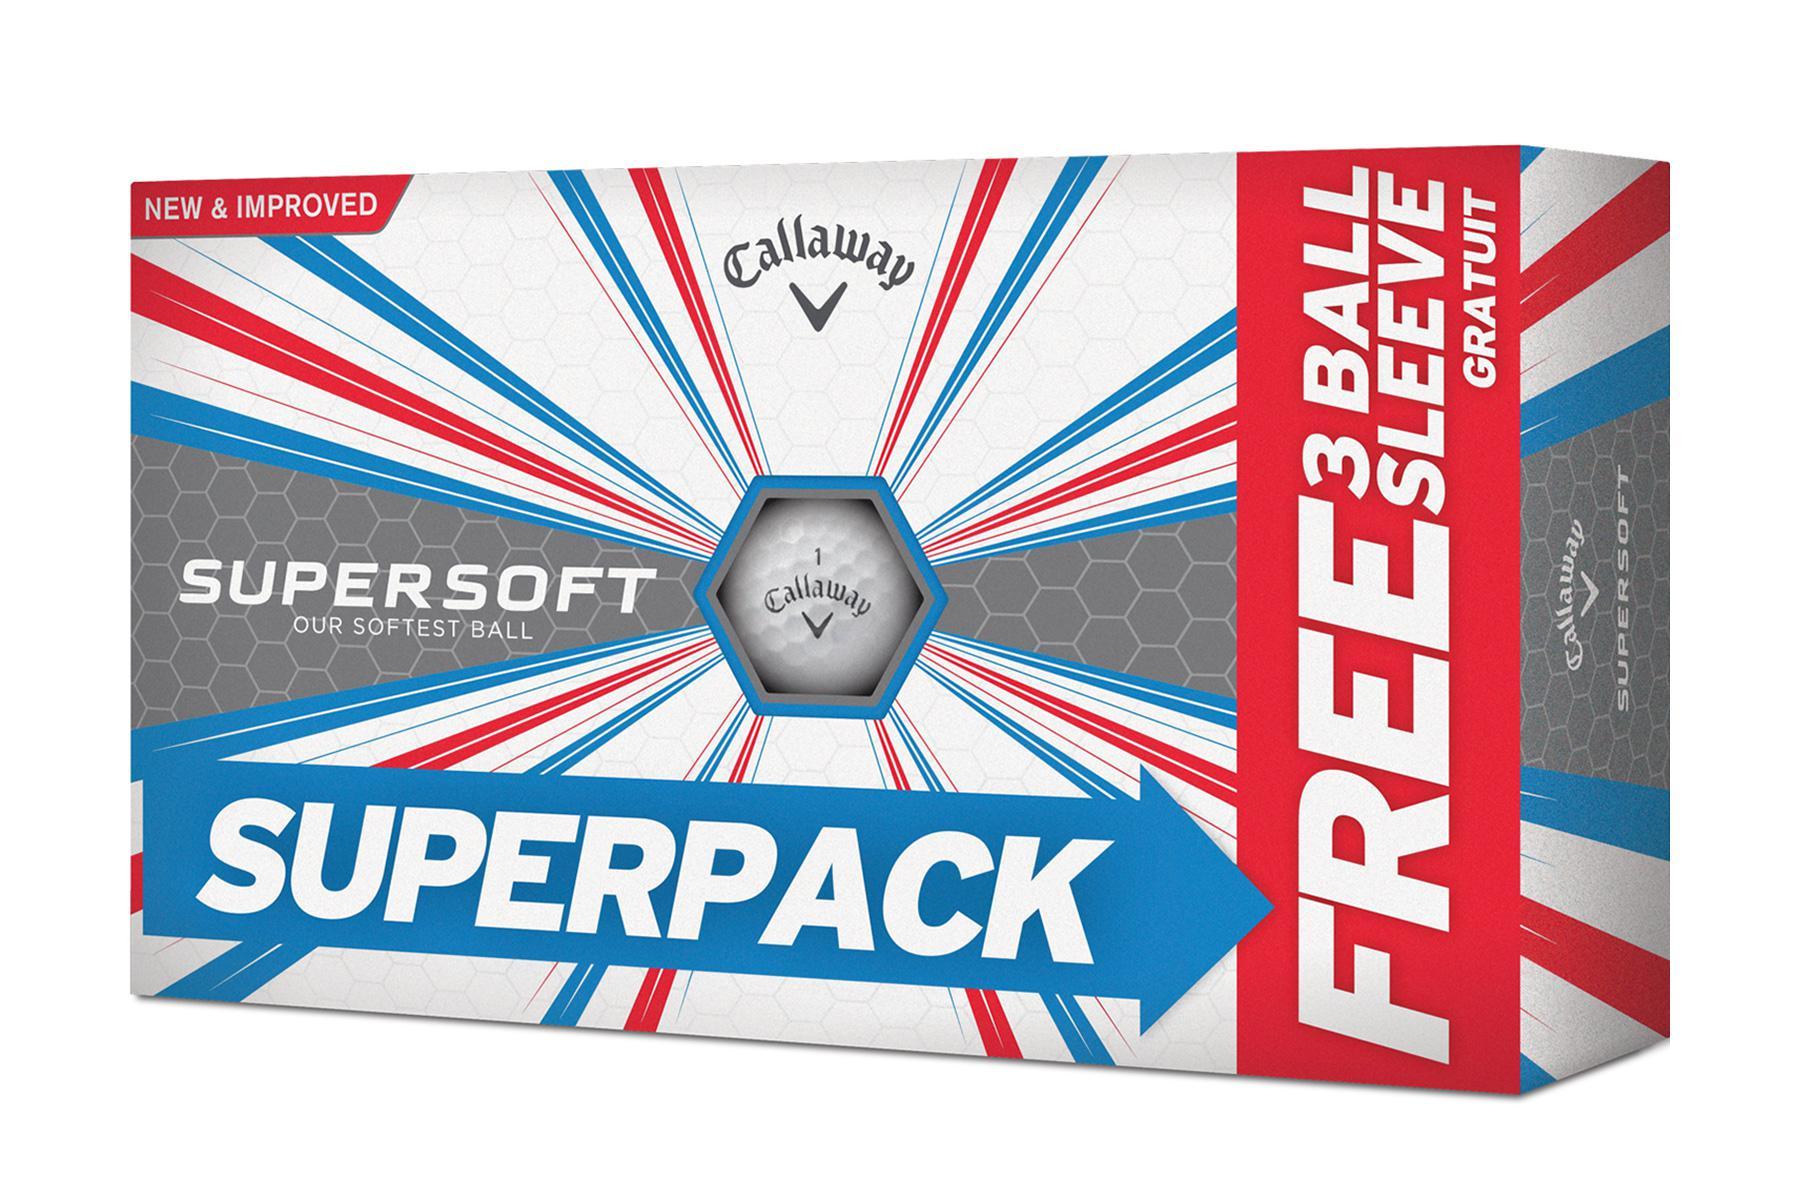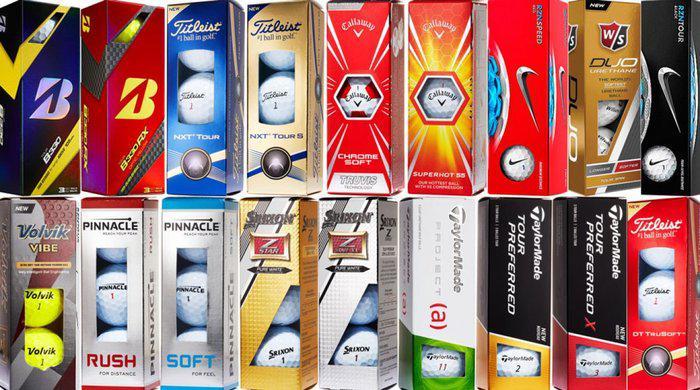The first image is the image on the left, the second image is the image on the right. Analyze the images presented: Is the assertion "All golf balls are in boxes, a total of at least nine boxes of balls are shown, and some boxes have hexagon 'windows' at the center." valid? Answer yes or no. Yes. The first image is the image on the left, the second image is the image on the right. Evaluate the accuracy of this statement regarding the images: "All the golf balls are in boxes.". Is it true? Answer yes or no. Yes. 